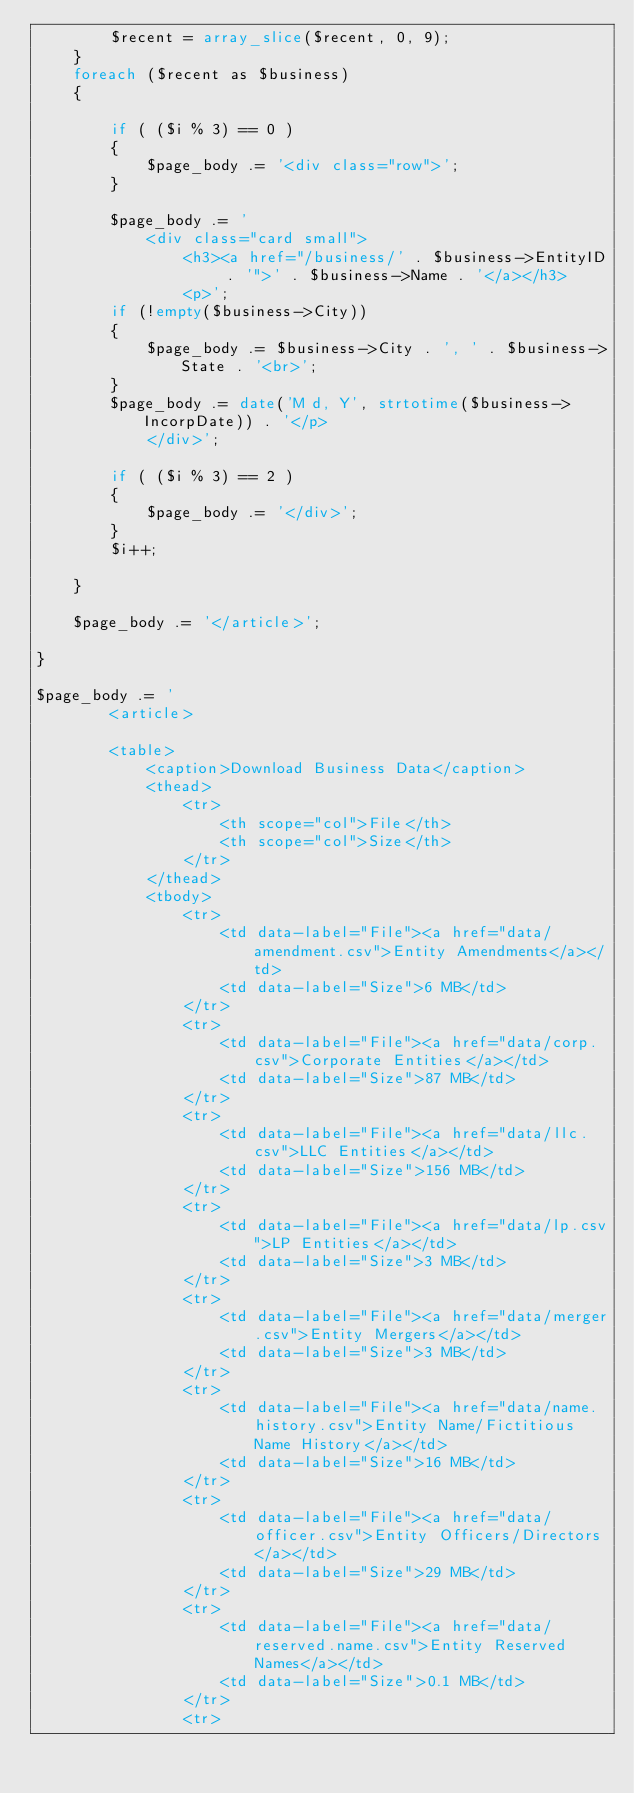<code> <loc_0><loc_0><loc_500><loc_500><_PHP_>		$recent = array_slice($recent, 0, 9);
	}
	foreach ($recent as $business)
	{

		if ( ($i % 3) == 0 )
		{
			$page_body .= '<div class="row">';
		}
		
		$page_body .= '
			<div class="card small">
				<h3><a href="/business/' . $business->EntityID . '">' . $business->Name . '</a></h3>
				<p>';
		if (!empty($business->City))
		{
			$page_body .= $business->City . ', ' . $business->State . '<br>';
		} 
		$page_body .= date('M d, Y', strtotime($business->IncorpDate)) . '</p>
			</div>';

		if ( ($i % 3) == 2 )
		{
			$page_body .= '</div>';
		}
		$i++;

	}

	$page_body .= '</article>';

}

$page_body .= '
		<article>

		<table>
			<caption>Download Business Data</caption>
			<thead>
				<tr>
					<th scope="col">File</th>
					<th scope="col">Size</th>
				</tr>
			</thead>
			<tbody>
				<tr>
					<td data-label="File"><a href="data/amendment.csv">Entity Amendments</a></td>
					<td data-label="Size">6 MB</td>
				</tr>
				<tr>
					<td data-label="File"><a href="data/corp.csv">Corporate Entities</a></td>
					<td data-label="Size">87 MB</td>
				</tr>
				<tr>
					<td data-label="File"><a href="data/llc.csv">LLC Entities</a></td>
					<td data-label="Size">156 MB</td>
				</tr>
				<tr>
					<td data-label="File"><a href="data/lp.csv">LP Entities</a></td>
					<td data-label="Size">3 MB</td>
				</tr>
				<tr>
					<td data-label="File"><a href="data/merger.csv">Entity Mergers</a></td>
					<td data-label="Size">3 MB</td>
				</tr>
				<tr>
					<td data-label="File"><a href="data/name.history.csv">Entity Name/Fictitious Name History</a></td>
					<td data-label="Size">16 MB</td>
				</tr>
				<tr>
					<td data-label="File"><a href="data/officer.csv">Entity Officers/Directors</a></td>
					<td data-label="Size">29 MB</td>
				</tr>
				<tr>
					<td data-label="File"><a href="data/reserved.name.csv">Entity Reserved Names</a></td>
					<td data-label="Size">0.1 MB</td>
				</tr>
				<tr></code> 